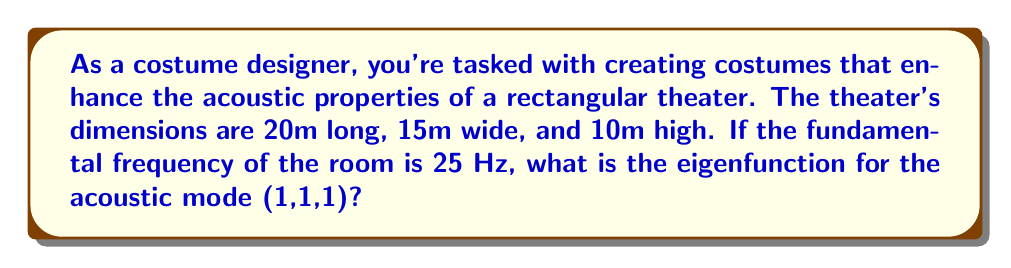Can you answer this question? To solve this problem, we'll follow these steps:

1) The eigenfunction for a rectangular room is given by:

   $$\psi_{l,m,n}(x,y,z) = \sin(\frac{l\pi x}{L_x})\sin(\frac{m\pi y}{L_y})\sin(\frac{n\pi z}{L_z})$$

   where $l$, $m$, and $n$ are integers, and $L_x$, $L_y$, and $L_z$ are the room dimensions.

2) We're given that $L_x = 20$m, $L_y = 15$m, and $L_z = 10$m.

3) For the (1,1,1) mode, $l = m = n = 1$.

4) Substituting these values into the eigenfunction equation:

   $$\psi_{1,1,1}(x,y,z) = \sin(\frac{\pi x}{20})\sin(\frac{\pi y}{15})\sin(\frac{\pi z}{10})$$

5) This is the final form of the eigenfunction for the (1,1,1) mode.

Note: The fundamental frequency information (25 Hz) is not needed for this particular question, but it could be used to calculate other acoustic properties of the room.
Answer: $$\sin(\frac{\pi x}{20})\sin(\frac{\pi y}{15})\sin(\frac{\pi z}{10})$$ 